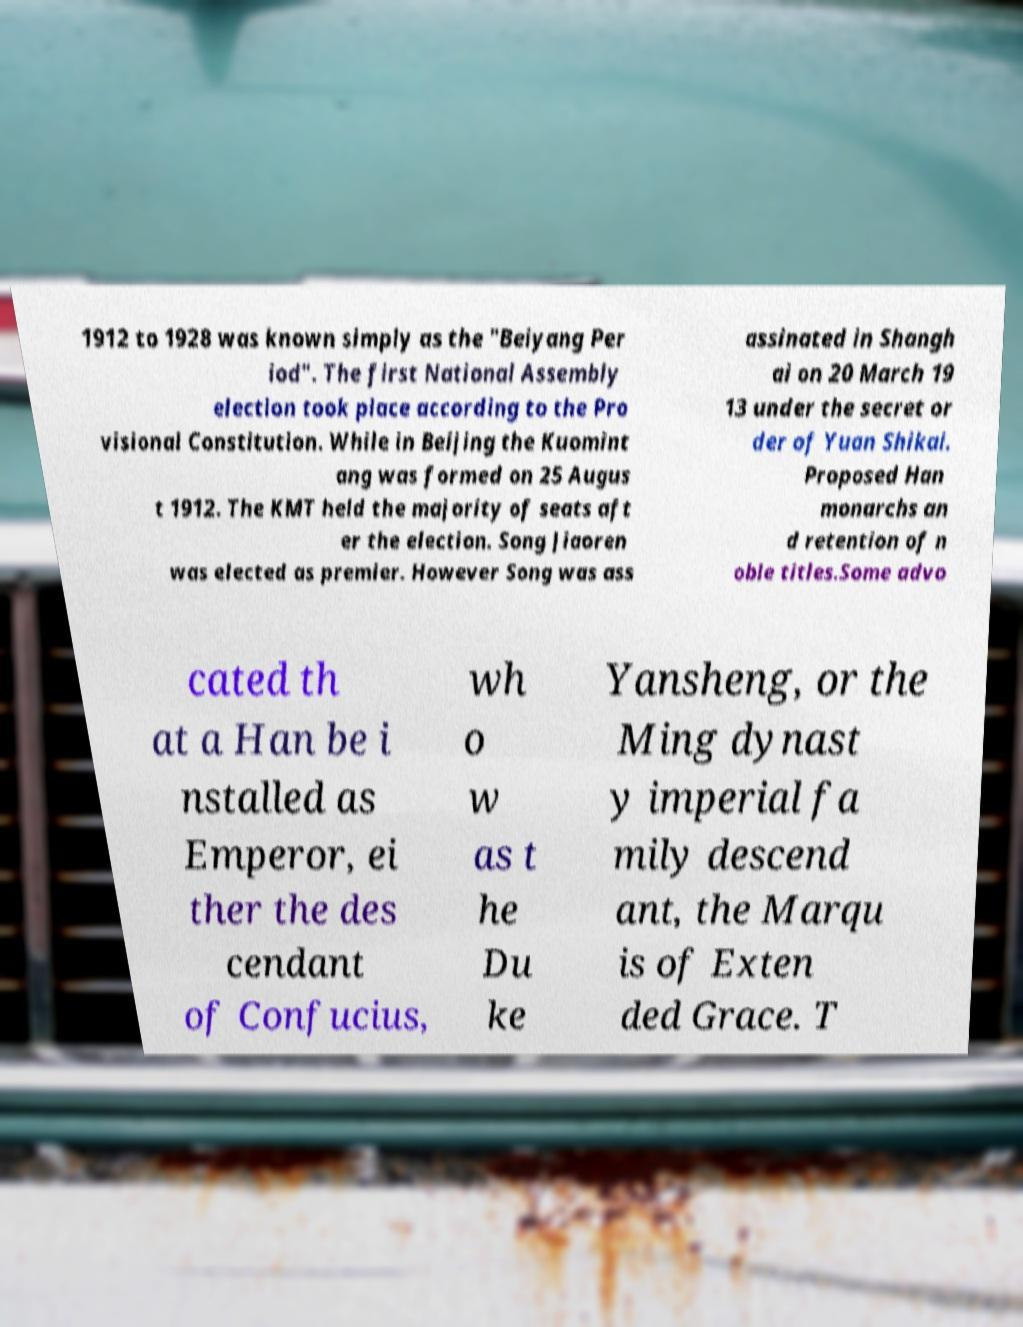Could you assist in decoding the text presented in this image and type it out clearly? 1912 to 1928 was known simply as the "Beiyang Per iod". The first National Assembly election took place according to the Pro visional Constitution. While in Beijing the Kuomint ang was formed on 25 Augus t 1912. The KMT held the majority of seats aft er the election. Song Jiaoren was elected as premier. However Song was ass assinated in Shangh ai on 20 March 19 13 under the secret or der of Yuan Shikai. Proposed Han monarchs an d retention of n oble titles.Some advo cated th at a Han be i nstalled as Emperor, ei ther the des cendant of Confucius, wh o w as t he Du ke Yansheng, or the Ming dynast y imperial fa mily descend ant, the Marqu is of Exten ded Grace. T 